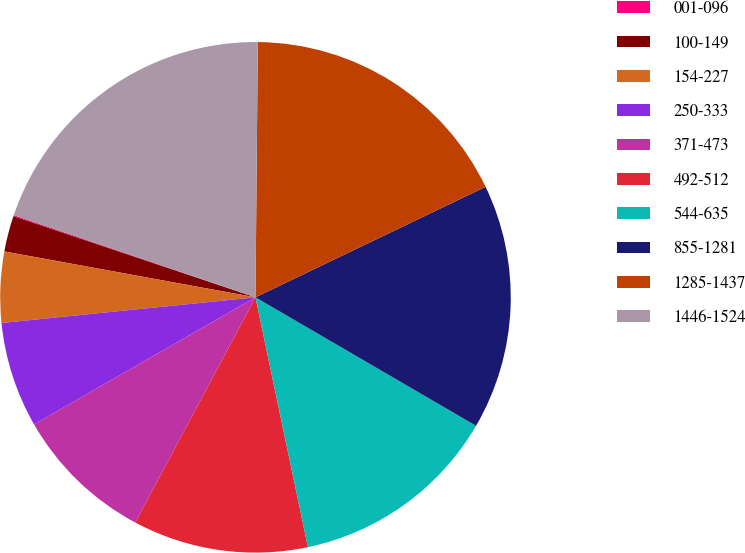<chart> <loc_0><loc_0><loc_500><loc_500><pie_chart><fcel>001-096<fcel>100-149<fcel>154-227<fcel>250-333<fcel>371-473<fcel>492-512<fcel>544-635<fcel>855-1281<fcel>1285-1437<fcel>1446-1524<nl><fcel>0.07%<fcel>2.27%<fcel>4.48%<fcel>6.69%<fcel>8.9%<fcel>11.1%<fcel>13.31%<fcel>15.52%<fcel>17.73%<fcel>19.93%<nl></chart> 